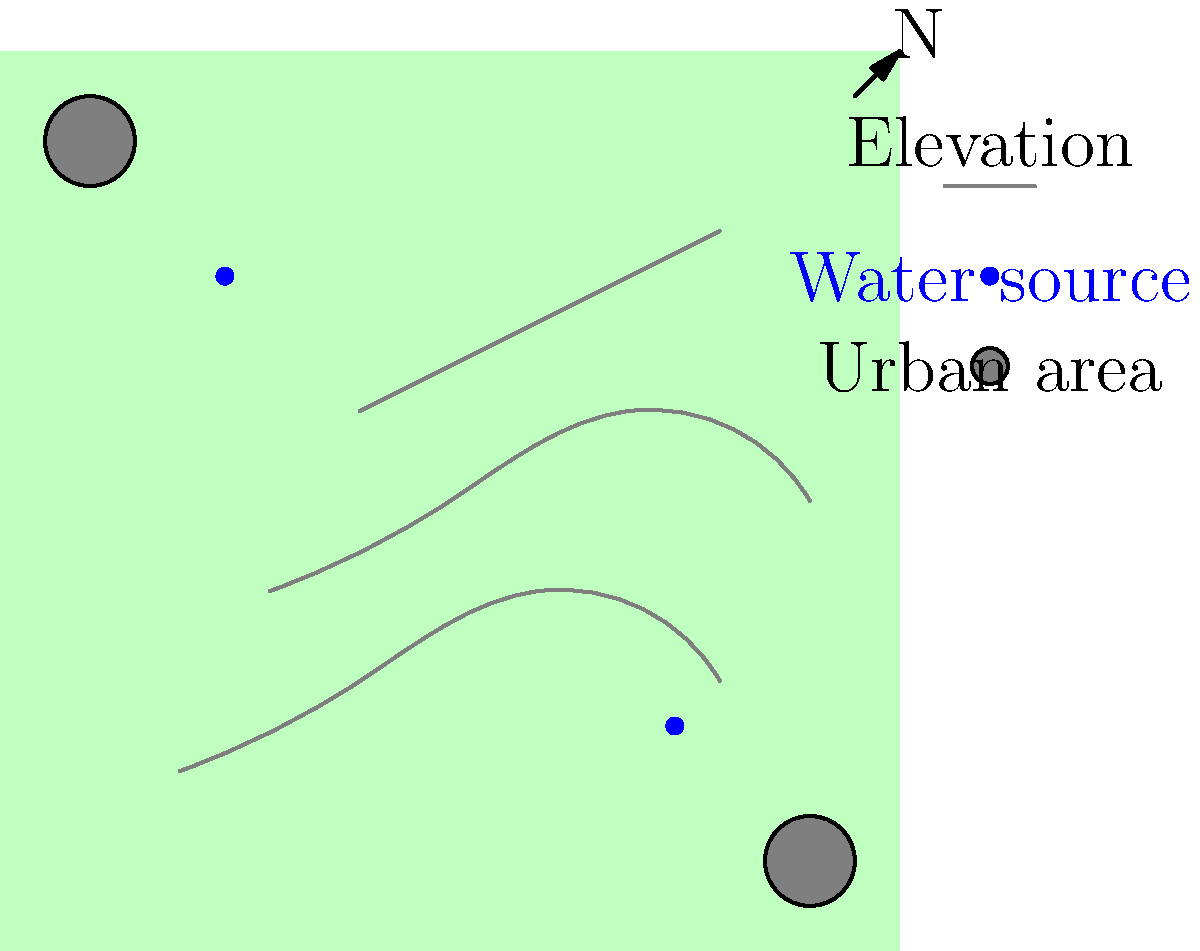Based on the topographical map of a Middle Eastern region shown above, which area would be most suitable for a large-scale solar farm installation? Consider factors such as elevation, proximity to water sources, and distance from urban areas. To determine the most suitable location for a large-scale solar farm, we need to consider several factors:

1. Elevation: Higher elevations generally receive more sunlight and have less atmospheric interference. The map shows elevation contours, with higher elevations towards the northeast.

2. Proximity to water sources: Solar panels require occasional cleaning, so having a water source nearby is beneficial. The map shows two water sources: one in the northwest and one in the southeast.

3. Distance from urban areas: Solar farms should be away from urban areas to minimize land-use conflicts and potential shading from buildings. The map shows two urban areas: one in the northwest corner and one in the southeast corner.

4. Available land area: Solar farms require large, flat areas for optimal installation.

Analyzing the map:
- The northeast quadrant has the highest elevation, which is favorable for solar energy production.
- There's a water source in the southeast, which could be useful for maintenance.
- Both urban areas are located at opposite corners, leaving ample space in between.
- The central-eastern area appears to have relatively flat terrain based on the contour lines.

Considering all these factors, the most suitable area for a large-scale solar farm installation would be in the central-eastern part of the region. This location offers:
- Relatively high elevation for good sun exposure
- Proximity to the southeastern water source
- Sufficient distance from both urban areas
- Apparently flat terrain for easier installation

This area provides a balance of the necessary factors for an optimal solar farm location.
Answer: Central-eastern area 